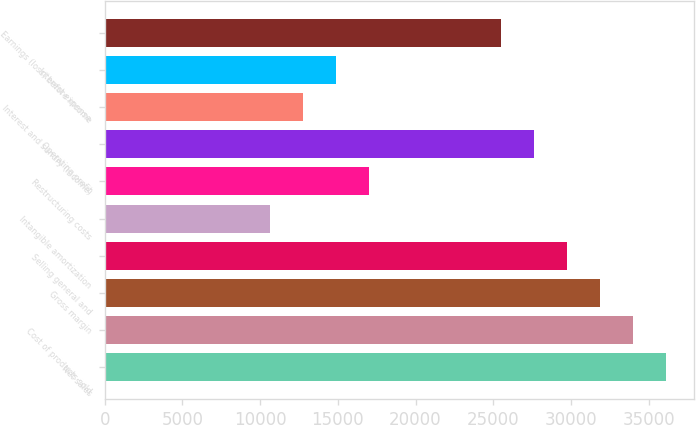<chart> <loc_0><loc_0><loc_500><loc_500><bar_chart><fcel>Net sales<fcel>Cost of products sold<fcel>Gross margin<fcel>Selling general and<fcel>Intangible amortization<fcel>Restructuring costs<fcel>Operating profit<fcel>Interest and sundry (income)<fcel>Interest expense<fcel>Earnings (loss) before income<nl><fcel>36126.8<fcel>34002<fcel>31877.2<fcel>29752.3<fcel>10628.9<fcel>17003.3<fcel>27627.5<fcel>12753.7<fcel>14878.5<fcel>25502.7<nl></chart> 